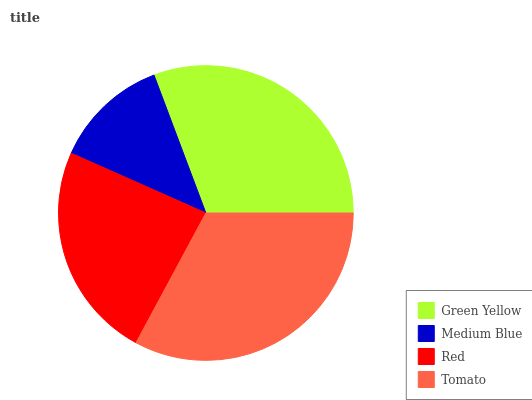Is Medium Blue the minimum?
Answer yes or no. Yes. Is Tomato the maximum?
Answer yes or no. Yes. Is Red the minimum?
Answer yes or no. No. Is Red the maximum?
Answer yes or no. No. Is Red greater than Medium Blue?
Answer yes or no. Yes. Is Medium Blue less than Red?
Answer yes or no. Yes. Is Medium Blue greater than Red?
Answer yes or no. No. Is Red less than Medium Blue?
Answer yes or no. No. Is Green Yellow the high median?
Answer yes or no. Yes. Is Red the low median?
Answer yes or no. Yes. Is Medium Blue the high median?
Answer yes or no. No. Is Green Yellow the low median?
Answer yes or no. No. 